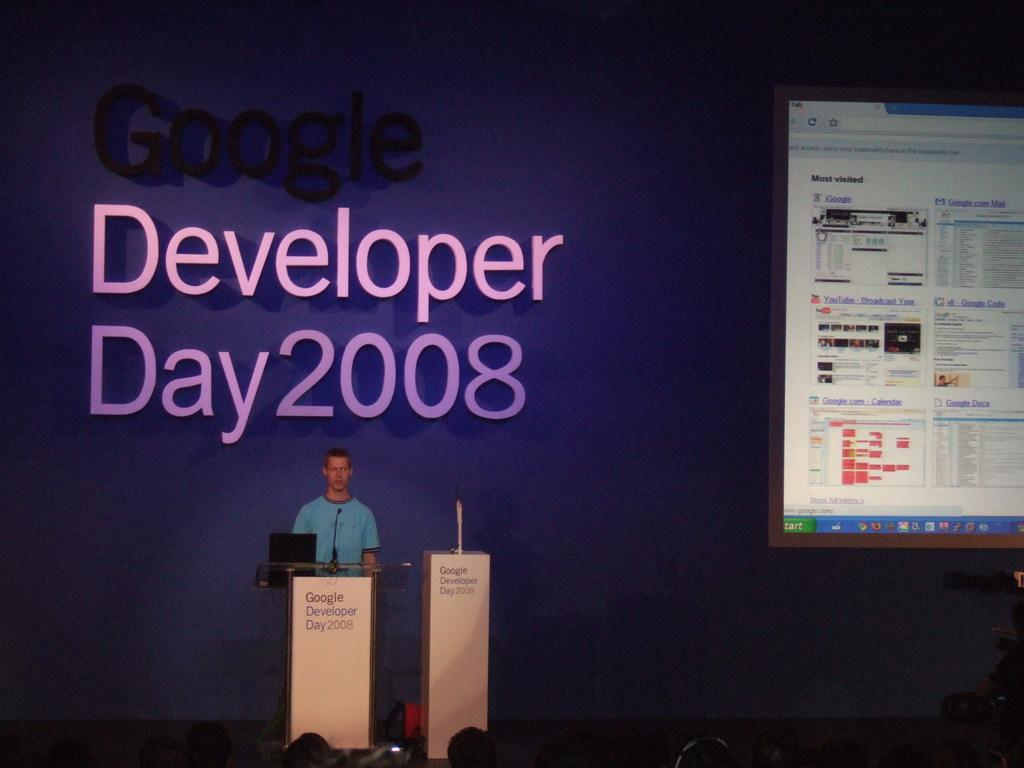Provide a one-sentence caption for the provided image. Speaker standing behind podium on Google Developer Day. 